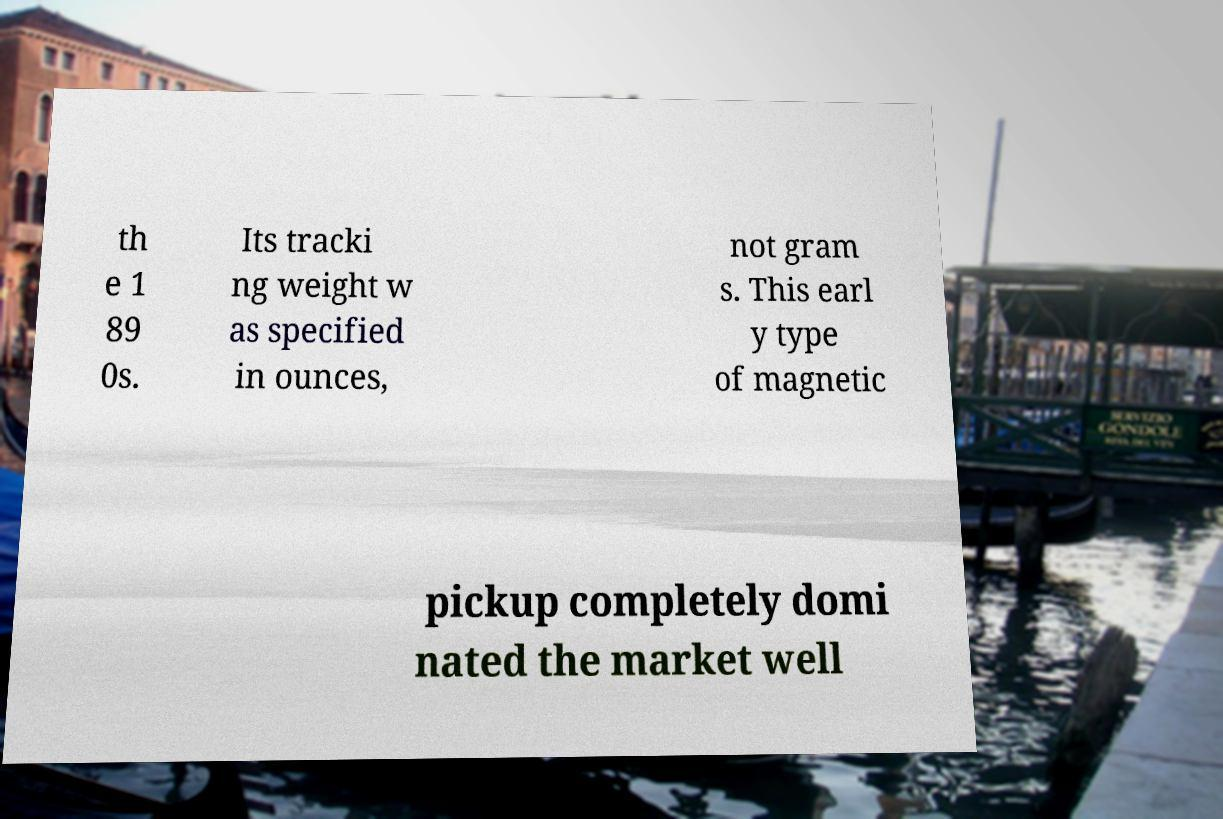Can you accurately transcribe the text from the provided image for me? th e 1 89 0s. Its tracki ng weight w as specified in ounces, not gram s. This earl y type of magnetic pickup completely domi nated the market well 